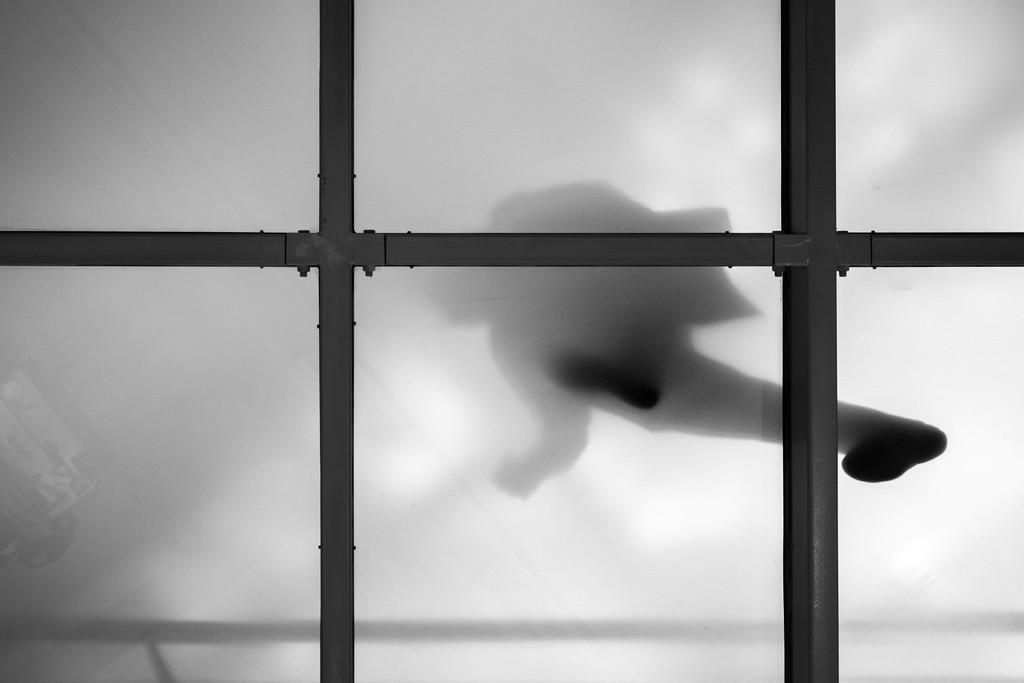Could you give a brief overview of what you see in this image? There is a glass window having a fence. In the background, there is a person walking on this window. And the background is white in color. 